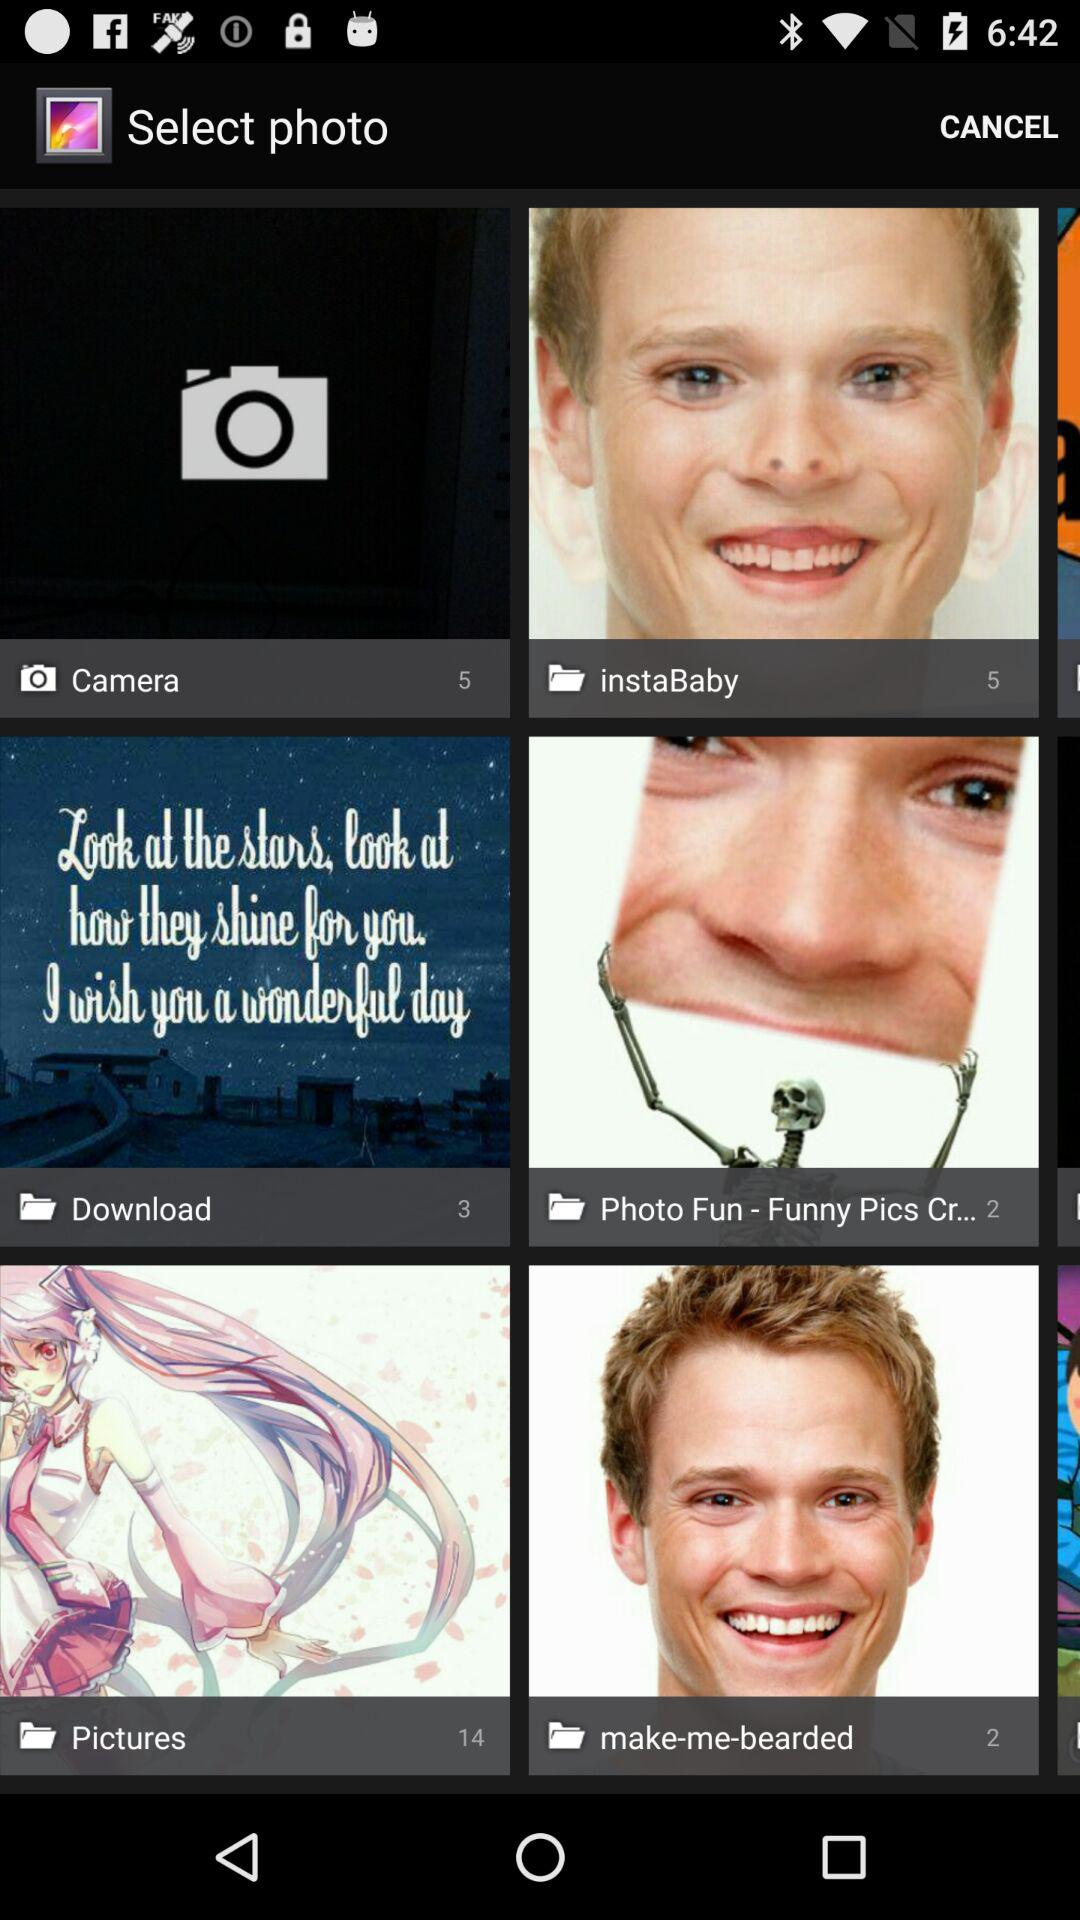How many images are there in the instaBaby? There are 5 images in the instaBaby. 